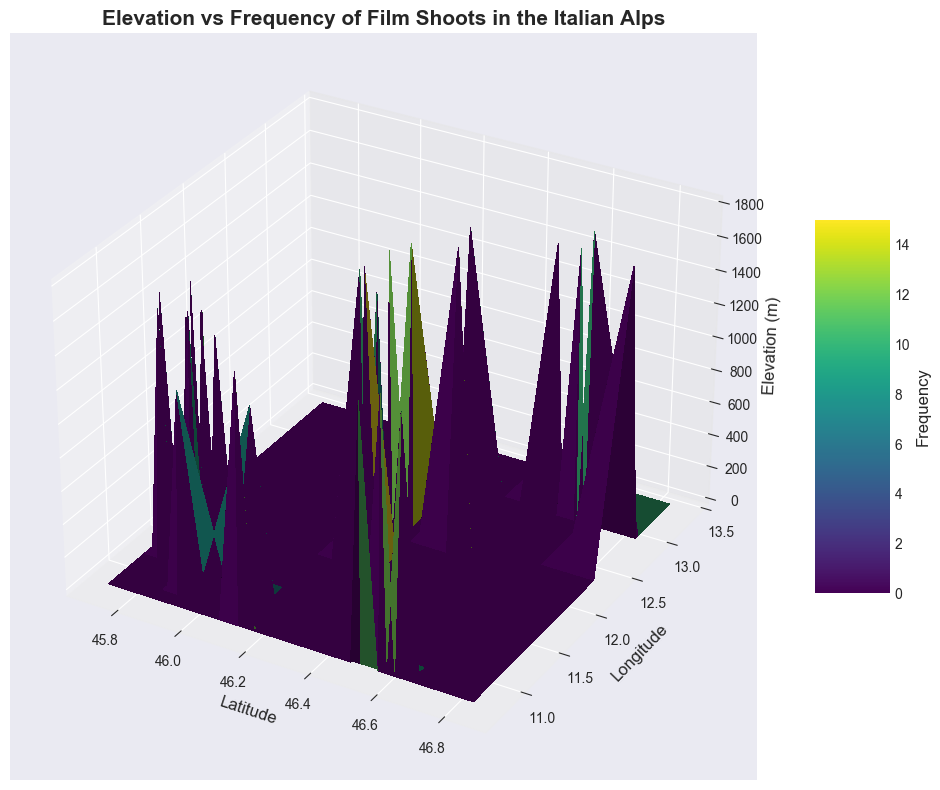Which location has the highest frequency of film shoots? Look at the color bar to match the highest frequency level represented on the plot, and identify the corresponding location by its coordinates on the surface.
Answer: 46.2834, 11.6768 (Elevation: 1800m, Frequency: 15) What is the average elevation of locations with a frequency of more than 10 film shoots? Identify the elevations of all locations where the frequency is greater than 10: 1500m, 1800m, 1300m, 1700m, 1400m, 1780m. Sum these elevations and divide by the number of locations (6). (1500 + 1800 + 1300 + 1700 + 1400 + 1780) / 6 = 9480 / 6 = 1580
Answer: 1580m Is there any noticeable pattern between elevation and frequency of film shoots? Examine the surface plot to observe whether higher elevations seem to correlate with higher or lower frequencies, or if there is no discernible pattern.
Answer: No clear pattern At which latitude and longitude intersection does the frequency of film shoots drop to its minimum? Look for the least intense color on the plot, then note its corresponding latitude and longitude coordinates from the axes.
Answer: 45.8654, 11.5012 How does the frequency change as elevation increases from 1200m to 1600m? Trace the surface plot along the elevation axis from 1200m to 1600m and observe the changes in color intensity, indicating changes in frequency. Measure frequency values at 1200m (8) and at 1600m (9, 12).
Answer: Generally increases What is the elevation range that has the highest concentration of film shoots? Locate the densest concentration of high-frequency areas on the surface plot and identify their elevation range by examining the y-axis.
Answer: 1400m - 1600m Which coordinates (latitude and longitude) correspond to the most frequent shoot at elevation 1700m? Identify the highest frequency location at the specific elevation of 1700m. Use the plot to locate coordinates.
Answer: 46.2760, 12.2905 Do locations with the same elevation always have the same film shoot frequency? Compare the frequencies at different coordinates with the same elevation by observing the color differences on the surface plot.
Answer: No What's the frequency for the location with latitude 45.8156 and longitude 11.5243? Locate the given latitude and longitude on the plot, and match it with the color bar to determine the frequency.
Answer: 8 Is there a location with both a high elevation and a low frequency of film shoots? Look for areas with high elevation (above 1500m) but with color indicating lower frequency (lighter colors).
Answer: Yes 